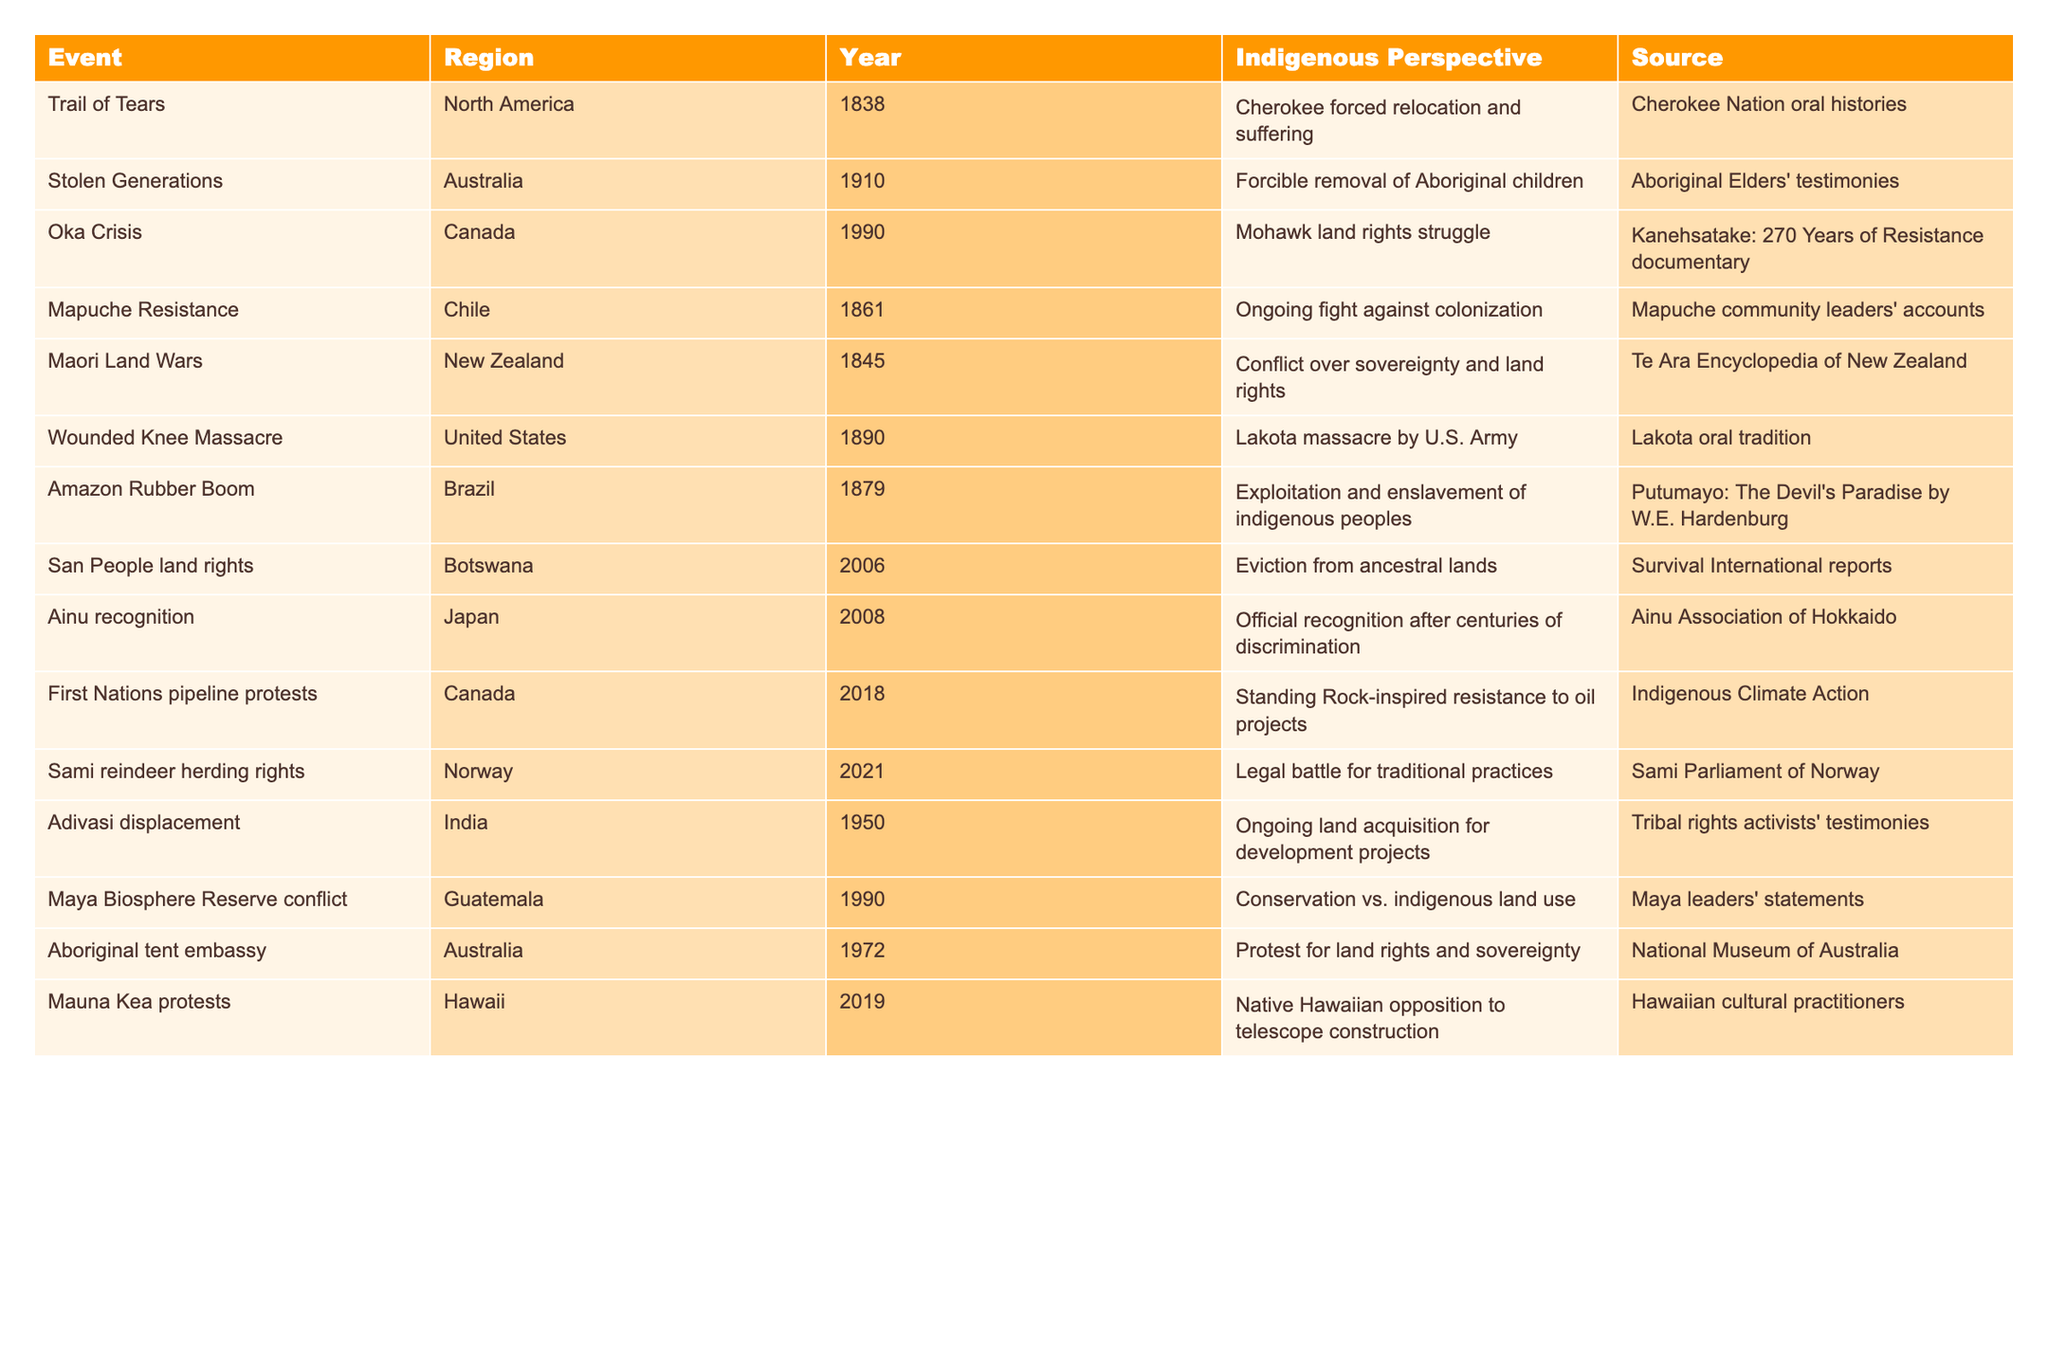What is the year of the Trail of Tears event? The "Trail of Tears" event occurred in the year 1838, as stated in the table.
Answer: 1838 Which region experienced the Stolen Generations event? The Stolen Generations event occurred in Australia, as indicated in the region column of the table.
Answer: Australia How many historical events listed occurred in the 1990s? There are three historical events in the table from the 1990s: the Oka Crisis in 1990, Maya Biosphere Reserve conflict in 1990, and First Nations pipeline protests in 2018 (however, 2018 is not in the 1990s). Therefore, only the Oka Crisis and Maya conflict count, for a total of two.
Answer: 2 What event is associated with the year 2008? The event associated with the year 2008 is Ainu recognition. This can be directly referenced from the year column beside the Ainu recognition entry.
Answer: Ainu recognition Is it true that the Maori Land Wars happened after the year 1850? Yes, according to the table, the Maori Land Wars occurred in 1845, which is before 1850. Therefore, the statement is false.
Answer: False Which event's perspective highlights exploitation and enslavement of indigenous peoples? The perspective that discusses exploitation and enslavement of indigenous peoples is related to the Amazon Rubber Boom event in Brazil, as mentioned in the Indigenous Perspective column.
Answer: Amazon Rubber Boom How many events listed involve land rights struggles? There are five events related to land rights struggles: Trail of Tears, Oka Crisis, Maori Land Wars, San People land rights, and First Nations pipeline protests, totaling five.
Answer: 5 What is the unique perspective expressed during Mauna Kea protests? The unique perspective during the Mauna Kea protests is the Native Hawaiian opposition to telescope construction, as stated under the Indigenous Perspective column.
Answer: Native Hawaiian opposition to telescope construction Which two countries are linked to the events regarding indigenous children's removal? The events regarding indigenous children's removal are linked to Australia (Stolen Generations) and India (Adivasi displacement). These can be cross-referenced through the table's event and region columns.
Answer: Australia and India What was the main focus of the Sami reindeer herding rights event? The Sami reindeer herding rights event focused on a legal battle for traditional practices, as described in the Indigenous Perspective column.
Answer: Legal battle for traditional practices Does the table contain any events related to the year 2021? Yes, there is an event in the year 2021 concerning Sami reindeer herding rights as per the year column of the table.
Answer: Yes 